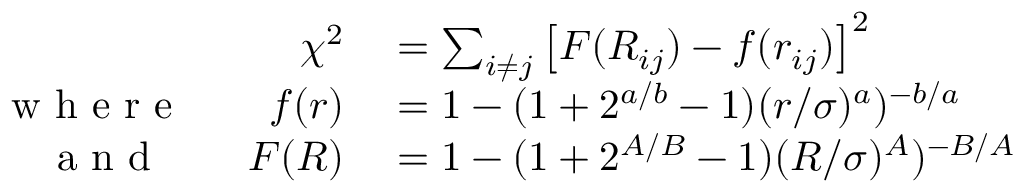Convert formula to latex. <formula><loc_0><loc_0><loc_500><loc_500>\begin{array} { r l } { \chi ^ { 2 } } & = \sum _ { i \ne j } \left [ F ( R _ { i j } ) - f ( r _ { i j } ) \right ] ^ { 2 } } \\ { w h e r e \quad f ( r ) } & = 1 - ( 1 + 2 ^ { a / b } - 1 ) ( r / \sigma ) ^ { a } ) ^ { - b / a } } \\ { a n d \quad F ( R ) } & = 1 - ( 1 + 2 ^ { A / B } - 1 ) ( R / \sigma ) ^ { A } ) ^ { - B / A } } \end{array}</formula> 